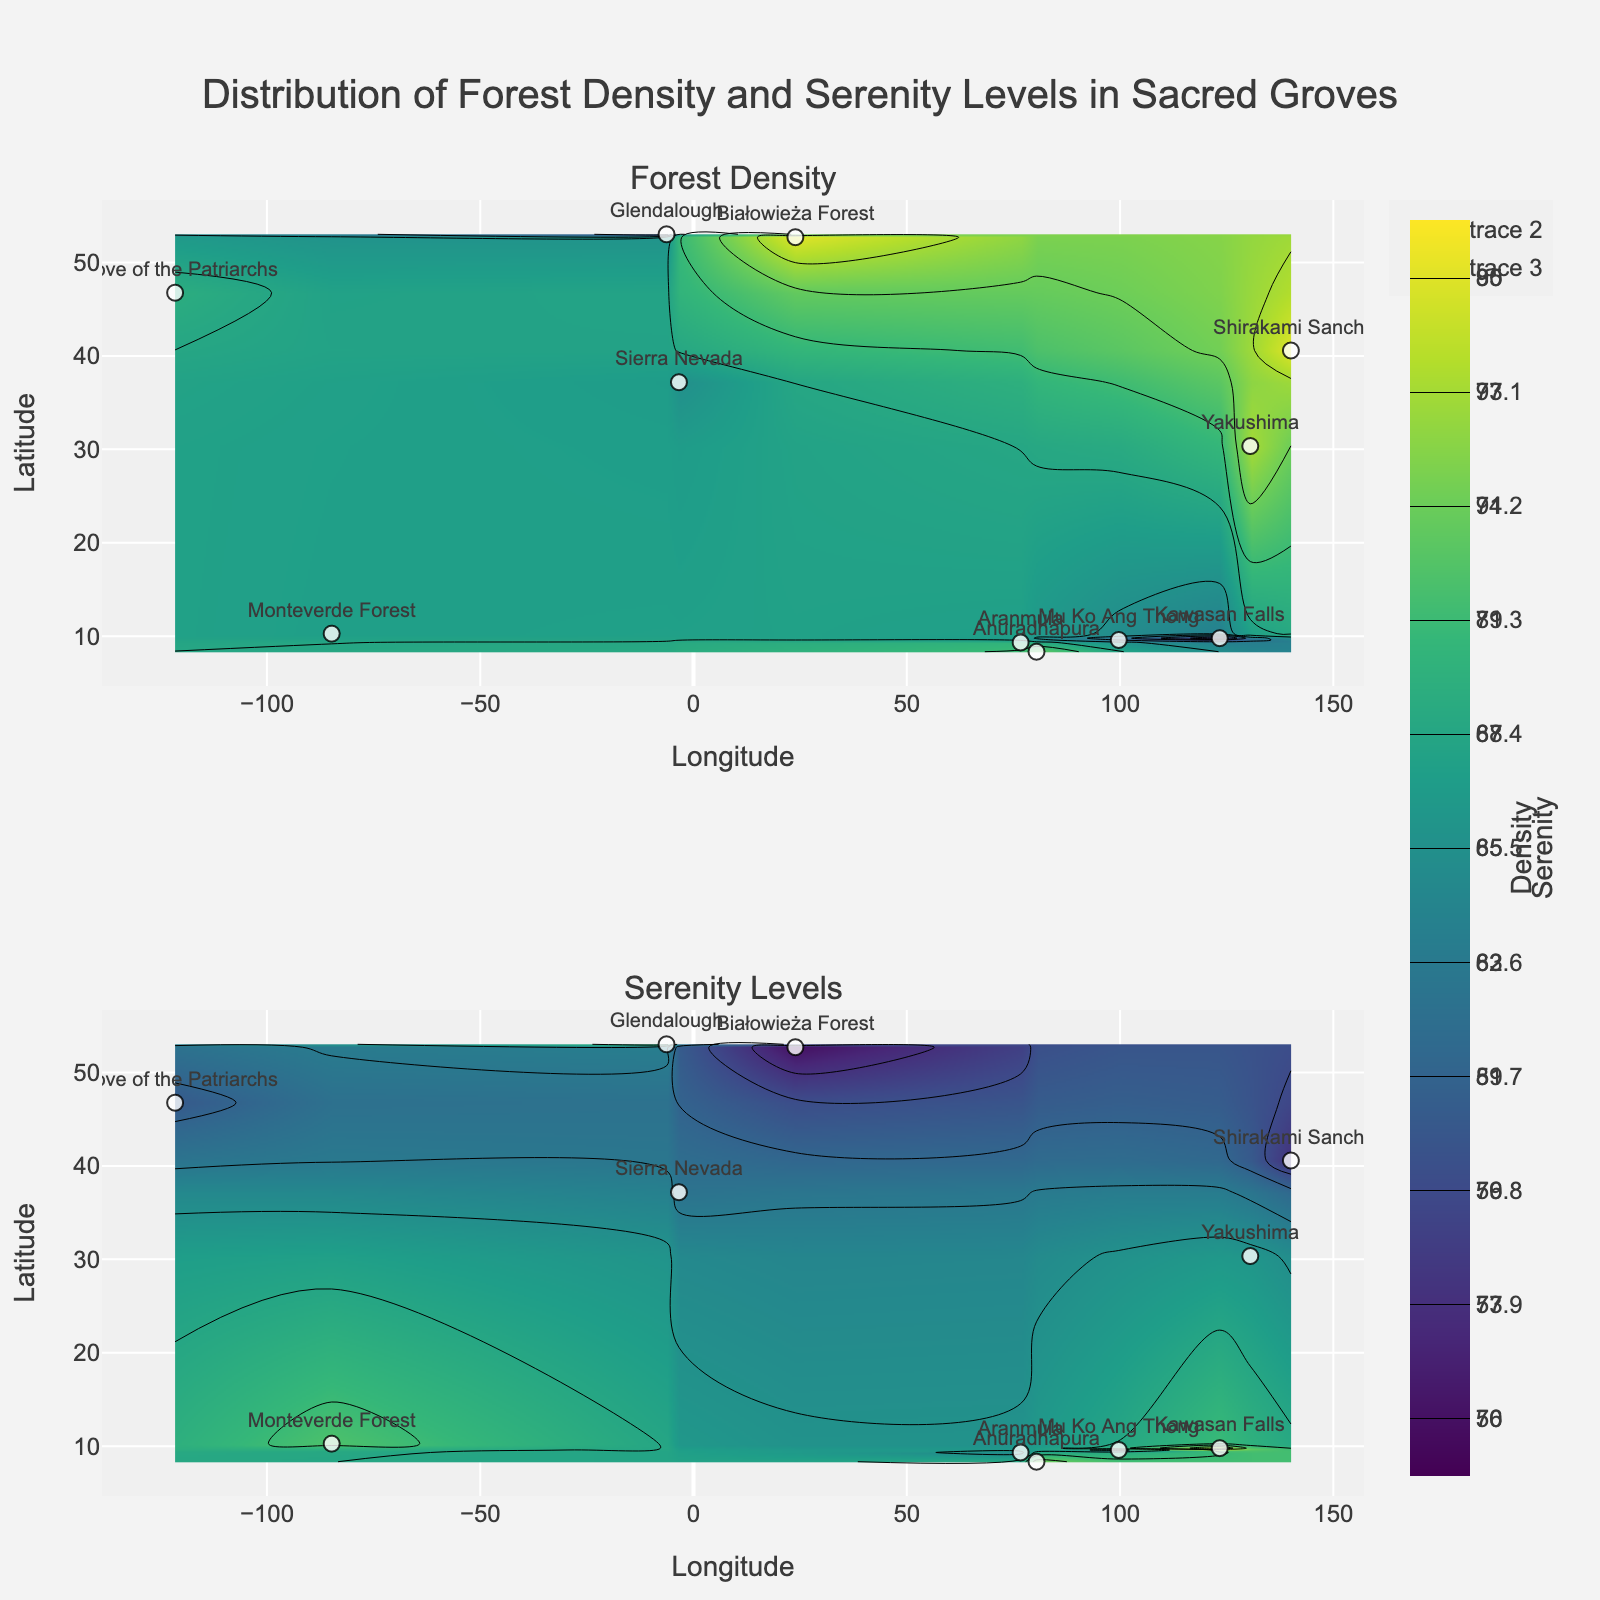What are the titles of the subplots? The figure has two subplots. Each subplot has a title at the top. The first subplot is titled "Forest Density" and the second is titled "Serenity Levels".
Answer: "Forest Density", "Serenity Levels" How many sacred groves are plotted in each subplot? The subplots mark the sacred groves as points with forest names. By counting the names or points, there are 11 sacred groves in both subplots.
Answer: 11 What is the latitude and longitude of the densest forest? The contour plot for "Forest Density" shows different bands corresponding to density levels, with darker colors indicating higher density. Shirakami Sanchi, Japan has the highest forest density, noted at 80.
Answer: Latitude: 40.5775, Longitude: 140.0536 Which sacred grove has the highest serenity level? The contour plot for "Serenity Levels" shows different bands corresponding to serenity levels, with darker colors indicating higher serenity. The Kawasan Falls in Cebu has the highest serenity level at 95.
Answer: Kawasan Falls, Cebu What is the average density of the forests in the dataset? To find the average density, sum all the density values and divide by the number of forests. Sum: 70 + 50 + 80 + 65 + 58 + 74 + 69 + 80 + 67 + 77 + 62 = 752. Average = 752 / 11.
Answer: 68.36 Which forest is located at the westernmost point on the map? By observing the longitude values, the forest with the most negative longitude will be the westernmost. The Sierra Nevada in Spain has the lowest longitude at -3.4138.
Answer: Sierra Nevada, Spain What latitude range do the forests with the highest serenity levels occupy? To find this, observe the darker bands in the Serenity Levels subplot and note their latitude range. The highest serenity levels (close to 95) are observed in groves around latitude 9 to 10 degrees.
Answer: 9 to 10 degrees Compare the forest density and serenity levels of Białowieża Forest and Monteverde Forest. Which has higher values in both aspects? Białowieża Forest has a density of 80 and serenity level of 76. Monteverde Forest has a density of 67 and serenity level of 90. Białowieża Forest has a higher density, while Monteverde Forest has a higher serenity level.
Answer: Monteverde Forest (Serenity), Białowieża Forest (Density) Where in the figure is Anuradhapura located, and how does its density and serenity compare to other groves? Anuradhapura is located in Sri Lanka (latitude 8.3447, longitude 80.4139) in the plot. Its density is 74 and serenity is 92, both above average compared to other groves.
Answer: Latitude: 8.3447, Longitude: 80.4139. Higher serenity, medium-high density 